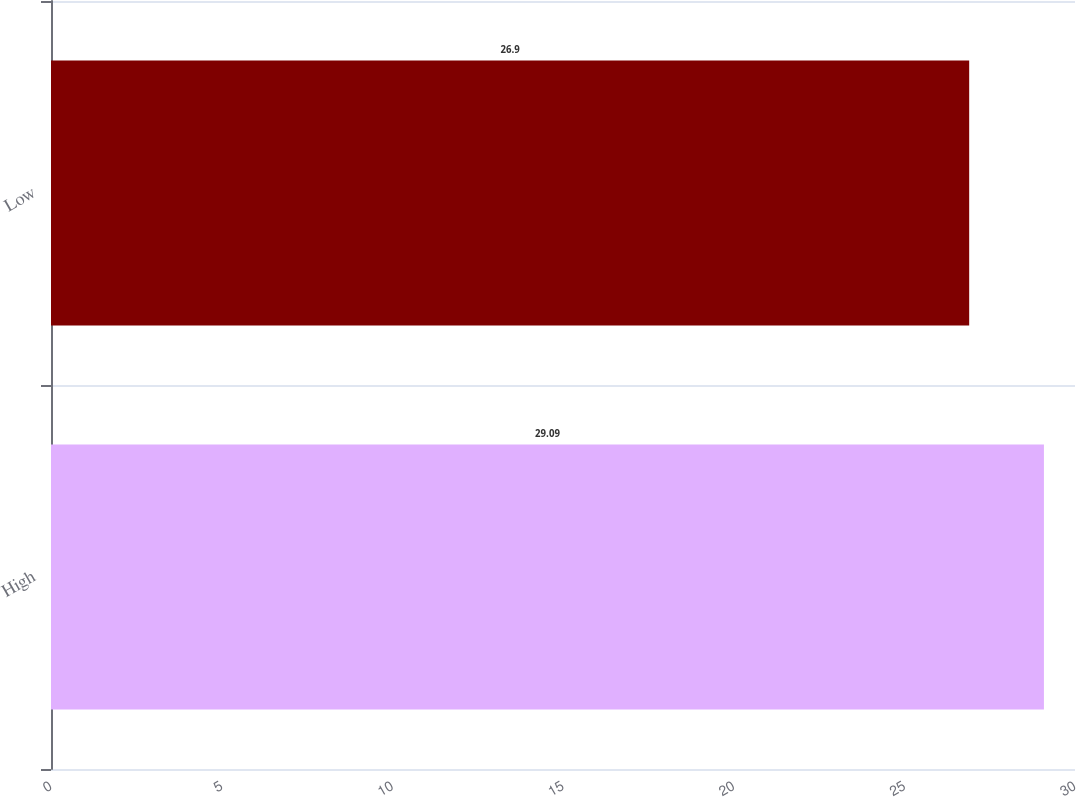Convert chart to OTSL. <chart><loc_0><loc_0><loc_500><loc_500><bar_chart><fcel>High<fcel>Low<nl><fcel>29.09<fcel>26.9<nl></chart> 